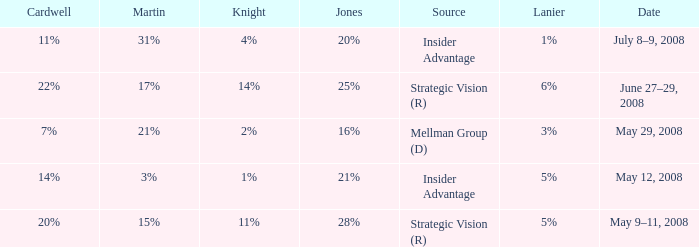What source has a Knight of 2%? Mellman Group (D). 